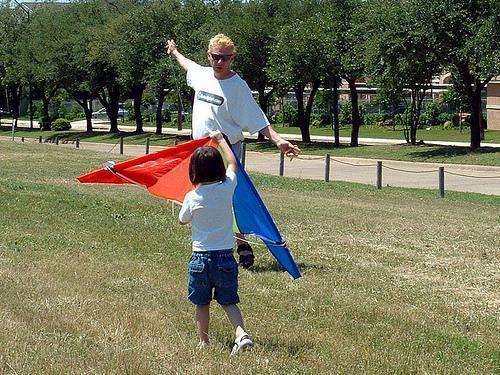How many people are in the photo?
Give a very brief answer. 2. How many people are holding a kite in this scene?
Give a very brief answer. 1. How many people can you see?
Give a very brief answer. 2. How many clock faces are visible?
Give a very brief answer. 0. 